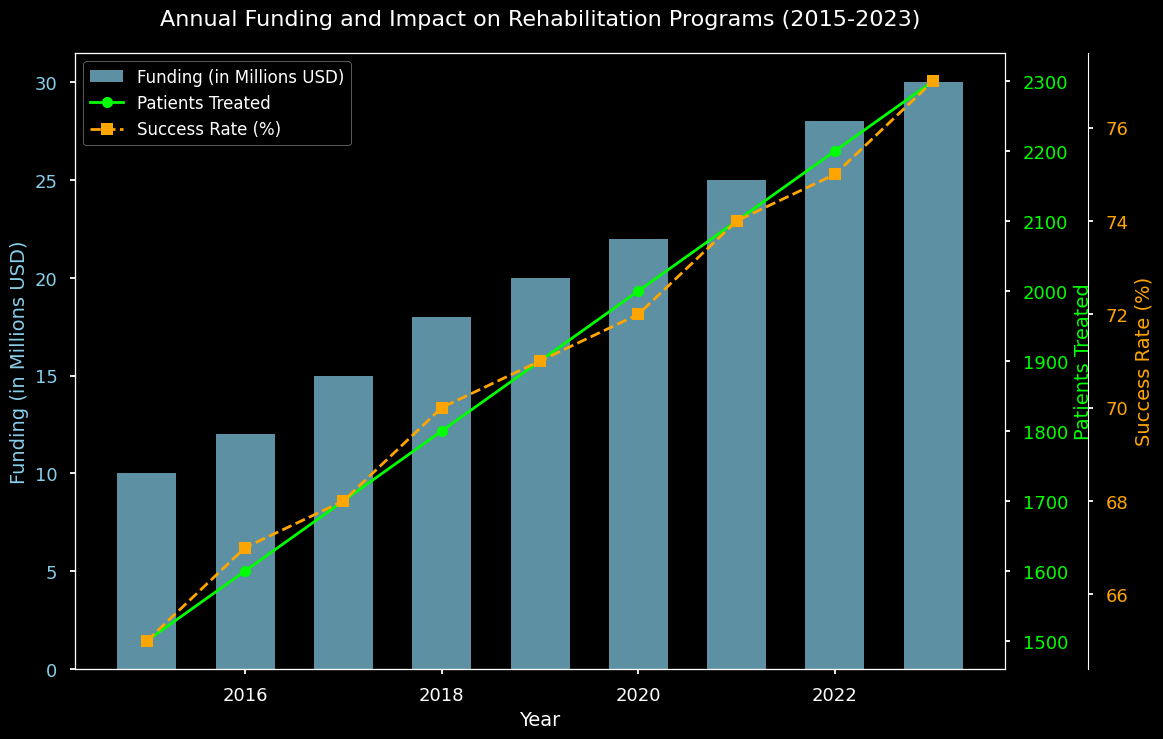What year shows the highest funding level? Look at the bar heights across different years. The highest bar represents the year with the highest funding level. The bar representing 2023 is the tallest.
Answer: 2023 What is the total funding from 2015 to 2023? Sum the funding values across all years from 2015 to 2023. The values are 10 + 12 + 15 + 18 + 20 + 22 + 25 + 28 + 30 = 180 million USD.
Answer: 180 million USD Which year experienced the highest success rate, and what was the success rate? Observe the line representing the success rate (orange, dashed line) and identify the peak year. The highest point on the line is in 2023 with a 77% success rate.
Answer: 2023, 77% How did the number of patients treated change from 2015 to 2023? Track the line representing the number of patients treated (lime, solid line) from 2015 to 2023. The number of patients treated increased each year, starting from 1500 in 2015 and ending at 2300 in 2023.
Answer: Increased from 1500 to 2300 What was the difference in the numbers of patients treated between 2016 and 2020? Subtract the number of patients treated in 2016 from the number treated in 2020. The respective values are 2000 and 1600. So, 2000 - 1600 = 400.
Answer: 400 Compare the funding levels between the first and last years. Compare the heights of the bars representing 2015 and 2023. The 2015 bar shows 10 million USD, and the 2023 bar shows 30 million USD. Thus, funding in 2023 is 20 million USD higher than in 2015.
Answer: 20 million USD higher in 2023 What is the average success rate from 2015 to 2023? Sum all the success rates and divide by the total number of years. The sum is 65 + 67 + 68 + 70 + 71 + 72 + 74 + 75 + 77 = 639. The average success rate is 639 / 9 ≈ 71%.
Answer: 71% Which years have a funding level greater than 20 million USD? Look at the bars representing each year's funding. Funding levels surpass 20 million USD from 2020 onward. These years are 2020, 2021, 2022, and 2023.
Answer: 2020, 2021, 2022, 2023 